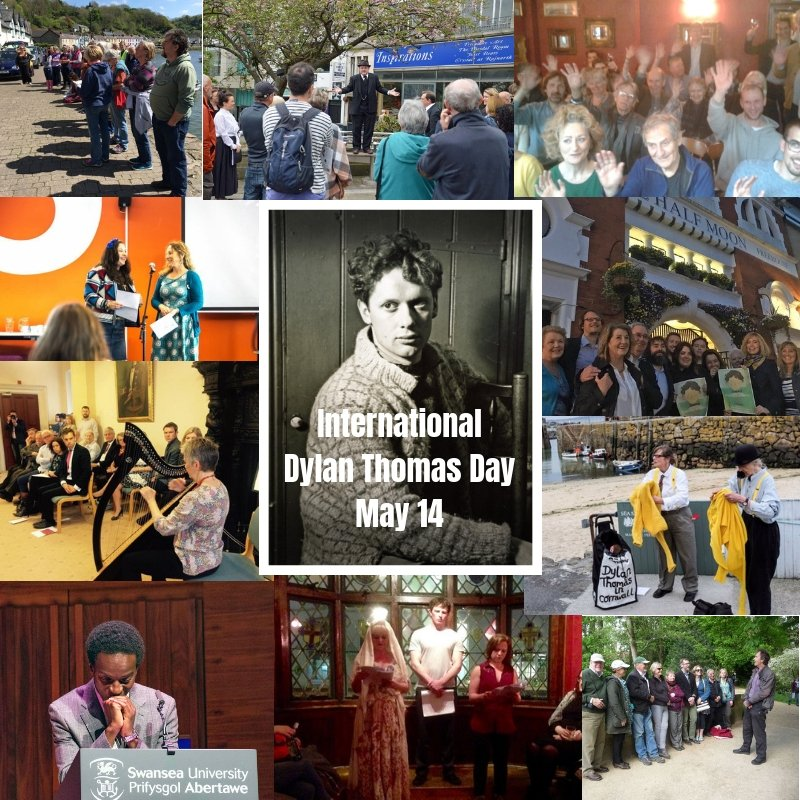Can you describe the activities happening in the different photos within this collage? Certainly! The collage showcases various events commemorating International Dylan Thomas Day. In one photo, a group of people gathers around a blue plaque, possibly listening to a guide narrating details about Dylan Thomas. Another image captures a lively literary reading session, while a third features an outdoor recital with a performer playing the harp. There are also groups of people engaged in what appears to be a dramatic performance, a lecture at a university podium, and evening gatherings outside an establishment—likely sharing stories or engaging in discussions about Dylan Thomas and his works. 